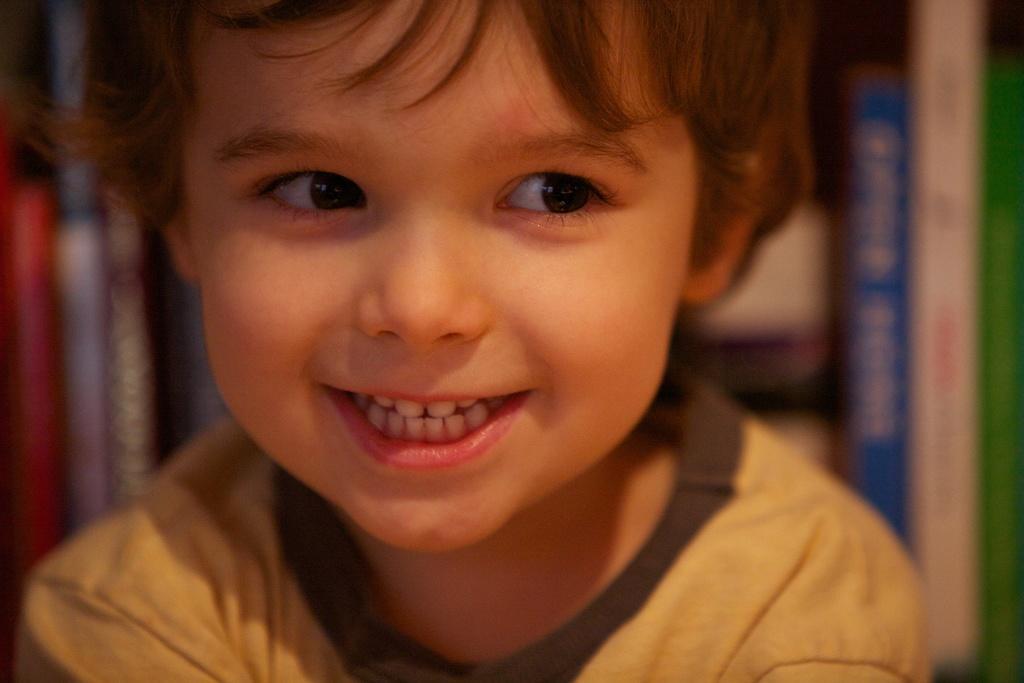How would you summarize this image in a sentence or two? In this image I can see a boy in the front and I can see he is wearing yellow colour t-shirt. I can also see smile on his face. In the background I can see number of books and I can see this image is little bit blurry in the background. 